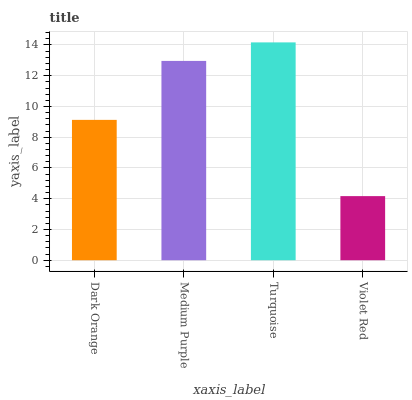Is Violet Red the minimum?
Answer yes or no. Yes. Is Turquoise the maximum?
Answer yes or no. Yes. Is Medium Purple the minimum?
Answer yes or no. No. Is Medium Purple the maximum?
Answer yes or no. No. Is Medium Purple greater than Dark Orange?
Answer yes or no. Yes. Is Dark Orange less than Medium Purple?
Answer yes or no. Yes. Is Dark Orange greater than Medium Purple?
Answer yes or no. No. Is Medium Purple less than Dark Orange?
Answer yes or no. No. Is Medium Purple the high median?
Answer yes or no. Yes. Is Dark Orange the low median?
Answer yes or no. Yes. Is Violet Red the high median?
Answer yes or no. No. Is Turquoise the low median?
Answer yes or no. No. 